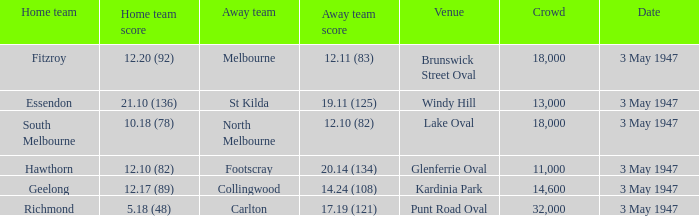Which venue did the away team score 12.10 (82)? Lake Oval. 